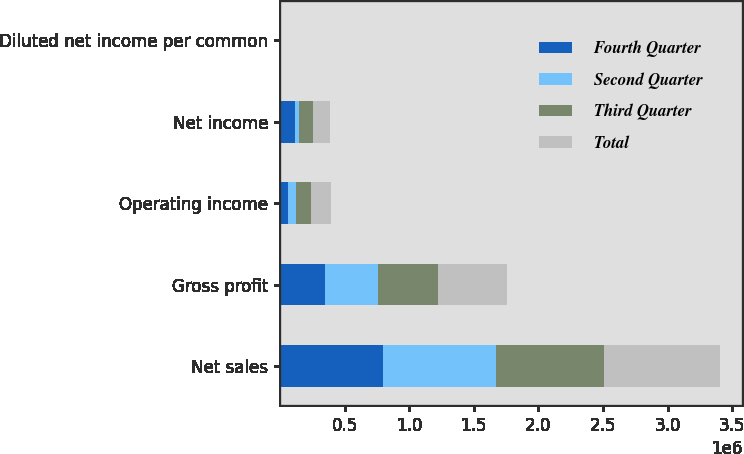Convert chart. <chart><loc_0><loc_0><loc_500><loc_500><stacked_bar_chart><ecel><fcel>Net sales<fcel>Gross profit<fcel>Operating income<fcel>Net income<fcel>Diluted net income per common<nl><fcel>Fourth Quarter<fcel>799411<fcel>348490<fcel>59104<fcel>113363<fcel>0.53<nl><fcel>Second Quarter<fcel>871364<fcel>410621<fcel>62760<fcel>33919<fcel>0.14<nl><fcel>Third Quarter<fcel>834366<fcel>465259<fcel>118074<fcel>107175<fcel>0.46<nl><fcel>Total<fcel>902666<fcel>532826<fcel>154087<fcel>136908<fcel>0.57<nl></chart> 